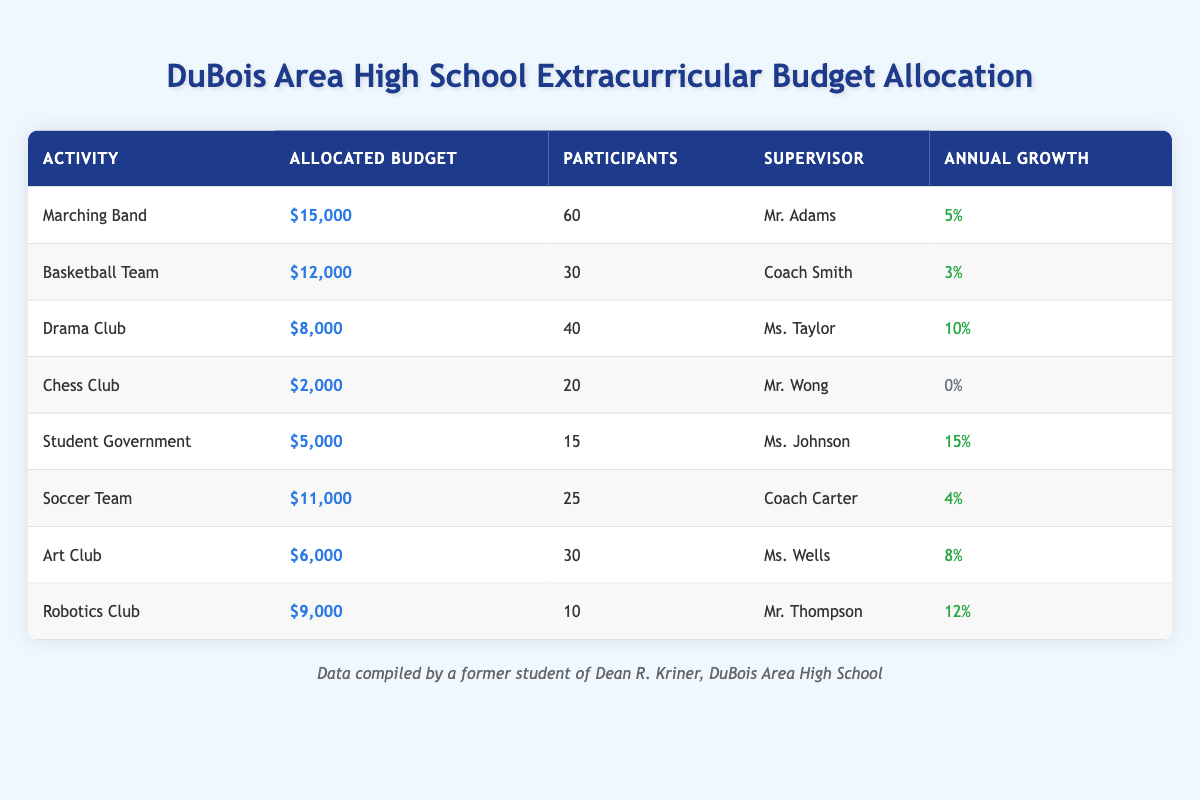What is the allocated budget for the Drama Club? The table shows the allocated budget for the Drama Club, which is listed under the "Allocated Budget" column. The amount is $8,000.
Answer: $8,000 How many participants are in the Marching Band? The number of participants in the Marching Band is listed in the corresponding row under the "Participants" column. The number is 60.
Answer: 60 Which extracurricular activity has the highest allocated budget? By comparing the "Allocated Budget" values, the Marching Band has the highest budget of $15,000.
Answer: Marching Band What is the annual growth percentage for the Student Government? The annual growth percentage for the Student Government is shown in the table under the "Annual Growth" column, indicating a growth of 15%.
Answer: 15% Which activity has the lowest number of participants? The number of participants for each activity is given in the "Participants" column. The Chess Club has the lowest with 20 participants.
Answer: Chess Club What is the total allocated budget for all extracurricular activities? To find the total, sum the allocated budgets for all activities: $15,000 + $12,000 + $8,000 + $2,000 + $5,000 + $11,000 + $6,000 + $9,000 = $68,000.
Answer: $68,000 Is the annual growth for the Robotics Club greater than the growth for the Art Club? The Robotics Club has an annual growth of 12%, while the Art Club has 8%. Since 12% > 8%, the statement is true.
Answer: Yes What is the average allocated budget for all activities listed in the table? The average is calculated by dividing the total allocated budget ($68,000) by the number of activities (8): $68,000 / 8 = $8,500.
Answer: $8,500 Which activity has a growth rate of 0%? The "Annual Growth" column specifies that the Chess Club has a growth rate of 0%.
Answer: Chess Club If you combine the budgets for the Basketball Team and the Soccer Team, how much is that in total? Add the allocated budgets for both teams: $12,000 (Basketball Team) + $11,000 (Soccer Team) = $23,000.
Answer: $23,000 Which activity has the highest number of participants, and what is that number? The Marching Band has the highest number of participants at 60, as shown in the "Participants" column.
Answer: 60 Is the total budget for the Drama Club and Art Club greater than $15,000? The total budget for the Drama Club is $8,000 and for the Art Club is $6,000. Their combined total is $8,000 + $6,000 = $14,000, which is less than $15,000.
Answer: No 